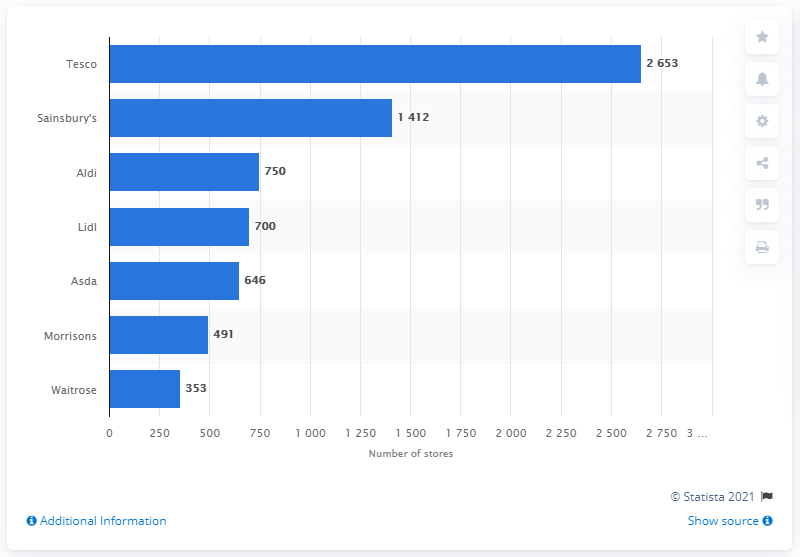Specify some key components in this picture. According to data collected in February 2018, Tesco was the supermarket with the highest number of stores in the United Kingdom. 